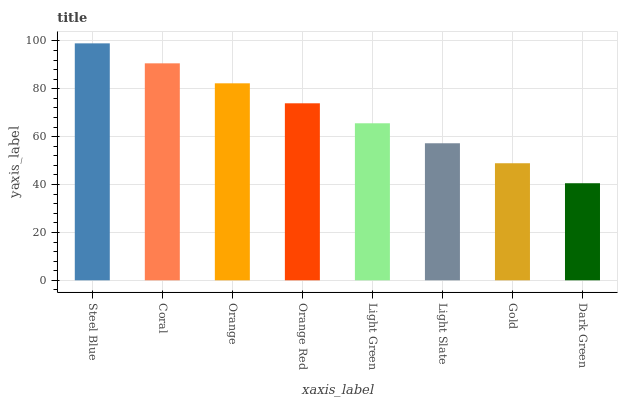Is Dark Green the minimum?
Answer yes or no. Yes. Is Steel Blue the maximum?
Answer yes or no. Yes. Is Coral the minimum?
Answer yes or no. No. Is Coral the maximum?
Answer yes or no. No. Is Steel Blue greater than Coral?
Answer yes or no. Yes. Is Coral less than Steel Blue?
Answer yes or no. Yes. Is Coral greater than Steel Blue?
Answer yes or no. No. Is Steel Blue less than Coral?
Answer yes or no. No. Is Orange Red the high median?
Answer yes or no. Yes. Is Light Green the low median?
Answer yes or no. Yes. Is Orange the high median?
Answer yes or no. No. Is Steel Blue the low median?
Answer yes or no. No. 